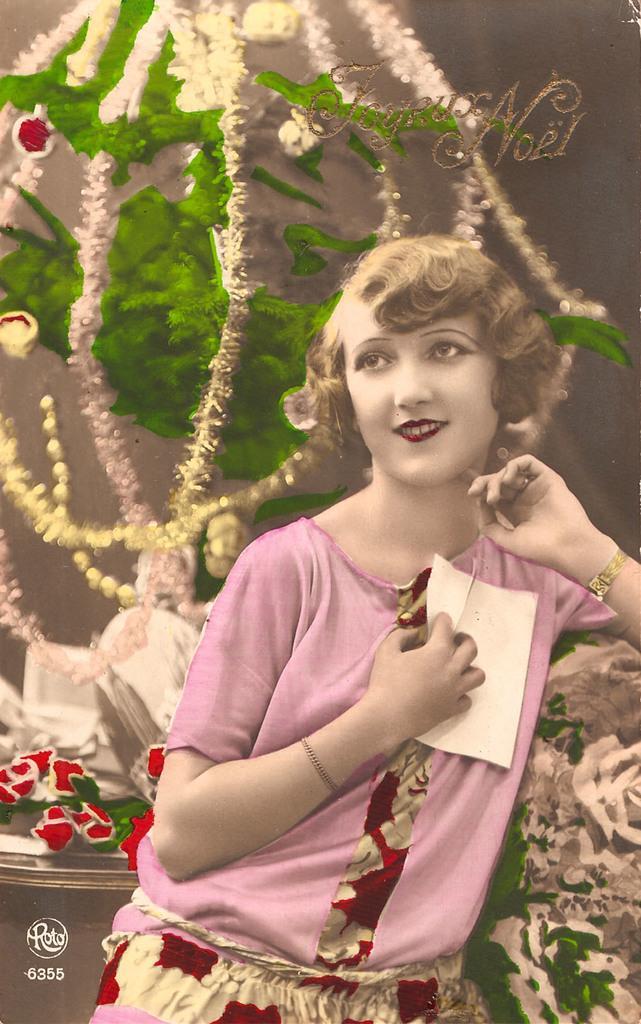Please provide a concise description of this image. In this picture we can see a woman holding a paper in her hand and smiling. We can see some text and numbers are visible in the bottom left. A text is visible in the top right. We can see some objects in the background. 